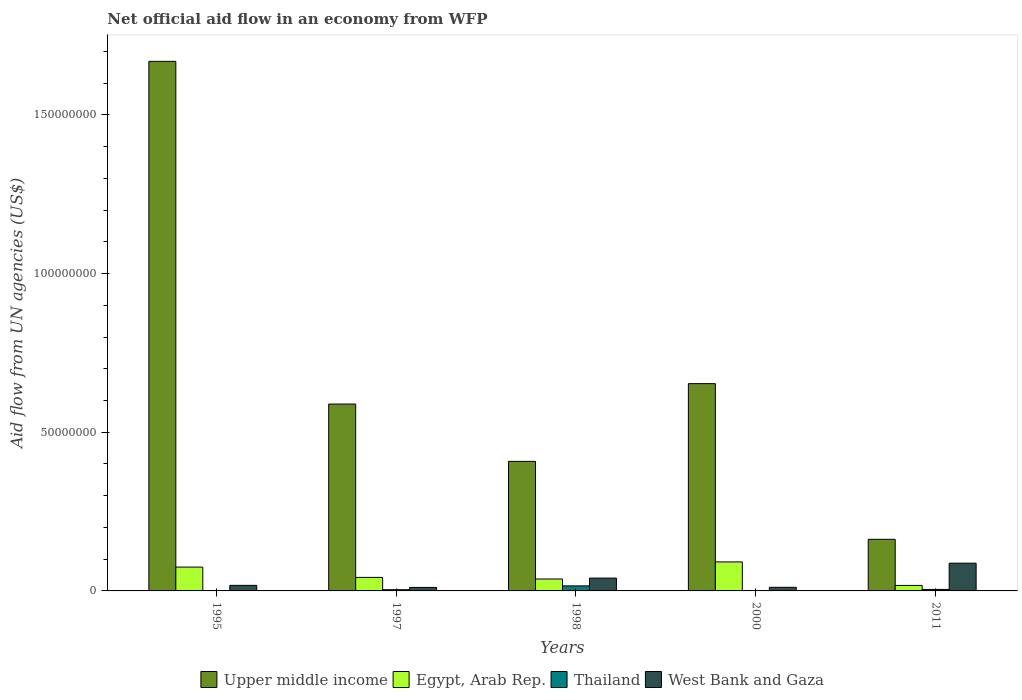How many groups of bars are there?
Provide a succinct answer. 5. Are the number of bars per tick equal to the number of legend labels?
Offer a very short reply. No. Are the number of bars on each tick of the X-axis equal?
Your answer should be very brief. No. How many bars are there on the 4th tick from the right?
Your answer should be very brief. 4. What is the label of the 1st group of bars from the left?
Provide a succinct answer. 1995. In how many cases, is the number of bars for a given year not equal to the number of legend labels?
Give a very brief answer. 1. What is the net official aid flow in Thailand in 2011?
Your answer should be very brief. 4.70e+05. Across all years, what is the maximum net official aid flow in West Bank and Gaza?
Ensure brevity in your answer.  8.74e+06. Across all years, what is the minimum net official aid flow in Upper middle income?
Keep it short and to the point. 1.63e+07. What is the total net official aid flow in West Bank and Gaza in the graph?
Offer a very short reply. 1.68e+07. What is the difference between the net official aid flow in Egypt, Arab Rep. in 1995 and that in 1997?
Your answer should be compact. 3.25e+06. What is the difference between the net official aid flow in Egypt, Arab Rep. in 1997 and the net official aid flow in Thailand in 1995?
Your answer should be very brief. 4.26e+06. What is the average net official aid flow in Egypt, Arab Rep. per year?
Your answer should be very brief. 5.28e+06. In the year 1998, what is the difference between the net official aid flow in Egypt, Arab Rep. and net official aid flow in Upper middle income?
Your answer should be very brief. -3.71e+07. What is the ratio of the net official aid flow in Thailand in 1998 to that in 2011?
Ensure brevity in your answer.  3.38. Is the net official aid flow in Egypt, Arab Rep. in 1998 less than that in 2000?
Your answer should be very brief. Yes. What is the difference between the highest and the second highest net official aid flow in Upper middle income?
Offer a terse response. 1.02e+08. What is the difference between the highest and the lowest net official aid flow in Egypt, Arab Rep.?
Offer a very short reply. 7.41e+06. Does the graph contain grids?
Offer a very short reply. No. Where does the legend appear in the graph?
Keep it short and to the point. Bottom center. What is the title of the graph?
Make the answer very short. Net official aid flow in an economy from WFP. What is the label or title of the X-axis?
Your response must be concise. Years. What is the label or title of the Y-axis?
Offer a very short reply. Aid flow from UN agencies (US$). What is the Aid flow from UN agencies (US$) in Upper middle income in 1995?
Your answer should be very brief. 1.67e+08. What is the Aid flow from UN agencies (US$) in Egypt, Arab Rep. in 1995?
Your answer should be very brief. 7.51e+06. What is the Aid flow from UN agencies (US$) in West Bank and Gaza in 1995?
Ensure brevity in your answer.  1.75e+06. What is the Aid flow from UN agencies (US$) in Upper middle income in 1997?
Your answer should be compact. 5.89e+07. What is the Aid flow from UN agencies (US$) in Egypt, Arab Rep. in 1997?
Keep it short and to the point. 4.26e+06. What is the Aid flow from UN agencies (US$) of Thailand in 1997?
Your answer should be very brief. 3.80e+05. What is the Aid flow from UN agencies (US$) in West Bank and Gaza in 1997?
Your response must be concise. 1.10e+06. What is the Aid flow from UN agencies (US$) in Upper middle income in 1998?
Make the answer very short. 4.08e+07. What is the Aid flow from UN agencies (US$) in Egypt, Arab Rep. in 1998?
Give a very brief answer. 3.76e+06. What is the Aid flow from UN agencies (US$) of Thailand in 1998?
Your response must be concise. 1.59e+06. What is the Aid flow from UN agencies (US$) in West Bank and Gaza in 1998?
Ensure brevity in your answer.  4.05e+06. What is the Aid flow from UN agencies (US$) of Upper middle income in 2000?
Offer a very short reply. 6.53e+07. What is the Aid flow from UN agencies (US$) of Egypt, Arab Rep. in 2000?
Your response must be concise. 9.14e+06. What is the Aid flow from UN agencies (US$) of West Bank and Gaza in 2000?
Ensure brevity in your answer.  1.14e+06. What is the Aid flow from UN agencies (US$) in Upper middle income in 2011?
Provide a succinct answer. 1.63e+07. What is the Aid flow from UN agencies (US$) in Egypt, Arab Rep. in 2011?
Provide a short and direct response. 1.73e+06. What is the Aid flow from UN agencies (US$) of Thailand in 2011?
Ensure brevity in your answer.  4.70e+05. What is the Aid flow from UN agencies (US$) of West Bank and Gaza in 2011?
Ensure brevity in your answer.  8.74e+06. Across all years, what is the maximum Aid flow from UN agencies (US$) of Upper middle income?
Offer a very short reply. 1.67e+08. Across all years, what is the maximum Aid flow from UN agencies (US$) of Egypt, Arab Rep.?
Make the answer very short. 9.14e+06. Across all years, what is the maximum Aid flow from UN agencies (US$) of Thailand?
Ensure brevity in your answer.  1.59e+06. Across all years, what is the maximum Aid flow from UN agencies (US$) in West Bank and Gaza?
Make the answer very short. 8.74e+06. Across all years, what is the minimum Aid flow from UN agencies (US$) in Upper middle income?
Give a very brief answer. 1.63e+07. Across all years, what is the minimum Aid flow from UN agencies (US$) in Egypt, Arab Rep.?
Keep it short and to the point. 1.73e+06. Across all years, what is the minimum Aid flow from UN agencies (US$) in West Bank and Gaza?
Give a very brief answer. 1.10e+06. What is the total Aid flow from UN agencies (US$) of Upper middle income in the graph?
Offer a terse response. 3.48e+08. What is the total Aid flow from UN agencies (US$) of Egypt, Arab Rep. in the graph?
Your response must be concise. 2.64e+07. What is the total Aid flow from UN agencies (US$) in Thailand in the graph?
Provide a short and direct response. 2.47e+06. What is the total Aid flow from UN agencies (US$) of West Bank and Gaza in the graph?
Give a very brief answer. 1.68e+07. What is the difference between the Aid flow from UN agencies (US$) in Upper middle income in 1995 and that in 1997?
Keep it short and to the point. 1.08e+08. What is the difference between the Aid flow from UN agencies (US$) of Egypt, Arab Rep. in 1995 and that in 1997?
Ensure brevity in your answer.  3.25e+06. What is the difference between the Aid flow from UN agencies (US$) of West Bank and Gaza in 1995 and that in 1997?
Your answer should be compact. 6.50e+05. What is the difference between the Aid flow from UN agencies (US$) of Upper middle income in 1995 and that in 1998?
Make the answer very short. 1.26e+08. What is the difference between the Aid flow from UN agencies (US$) of Egypt, Arab Rep. in 1995 and that in 1998?
Your response must be concise. 3.75e+06. What is the difference between the Aid flow from UN agencies (US$) of West Bank and Gaza in 1995 and that in 1998?
Your answer should be compact. -2.30e+06. What is the difference between the Aid flow from UN agencies (US$) in Upper middle income in 1995 and that in 2000?
Make the answer very short. 1.02e+08. What is the difference between the Aid flow from UN agencies (US$) of Egypt, Arab Rep. in 1995 and that in 2000?
Your response must be concise. -1.63e+06. What is the difference between the Aid flow from UN agencies (US$) in West Bank and Gaza in 1995 and that in 2000?
Offer a very short reply. 6.10e+05. What is the difference between the Aid flow from UN agencies (US$) of Upper middle income in 1995 and that in 2011?
Provide a short and direct response. 1.51e+08. What is the difference between the Aid flow from UN agencies (US$) of Egypt, Arab Rep. in 1995 and that in 2011?
Your response must be concise. 5.78e+06. What is the difference between the Aid flow from UN agencies (US$) in West Bank and Gaza in 1995 and that in 2011?
Make the answer very short. -6.99e+06. What is the difference between the Aid flow from UN agencies (US$) in Upper middle income in 1997 and that in 1998?
Your answer should be compact. 1.81e+07. What is the difference between the Aid flow from UN agencies (US$) in Egypt, Arab Rep. in 1997 and that in 1998?
Provide a succinct answer. 5.00e+05. What is the difference between the Aid flow from UN agencies (US$) of Thailand in 1997 and that in 1998?
Offer a very short reply. -1.21e+06. What is the difference between the Aid flow from UN agencies (US$) in West Bank and Gaza in 1997 and that in 1998?
Provide a succinct answer. -2.95e+06. What is the difference between the Aid flow from UN agencies (US$) of Upper middle income in 1997 and that in 2000?
Offer a terse response. -6.43e+06. What is the difference between the Aid flow from UN agencies (US$) in Egypt, Arab Rep. in 1997 and that in 2000?
Offer a very short reply. -4.88e+06. What is the difference between the Aid flow from UN agencies (US$) in Thailand in 1997 and that in 2000?
Your answer should be compact. 3.50e+05. What is the difference between the Aid flow from UN agencies (US$) in West Bank and Gaza in 1997 and that in 2000?
Make the answer very short. -4.00e+04. What is the difference between the Aid flow from UN agencies (US$) of Upper middle income in 1997 and that in 2011?
Ensure brevity in your answer.  4.26e+07. What is the difference between the Aid flow from UN agencies (US$) of Egypt, Arab Rep. in 1997 and that in 2011?
Your response must be concise. 2.53e+06. What is the difference between the Aid flow from UN agencies (US$) of West Bank and Gaza in 1997 and that in 2011?
Your answer should be very brief. -7.64e+06. What is the difference between the Aid flow from UN agencies (US$) of Upper middle income in 1998 and that in 2000?
Ensure brevity in your answer.  -2.45e+07. What is the difference between the Aid flow from UN agencies (US$) of Egypt, Arab Rep. in 1998 and that in 2000?
Give a very brief answer. -5.38e+06. What is the difference between the Aid flow from UN agencies (US$) in Thailand in 1998 and that in 2000?
Give a very brief answer. 1.56e+06. What is the difference between the Aid flow from UN agencies (US$) in West Bank and Gaza in 1998 and that in 2000?
Make the answer very short. 2.91e+06. What is the difference between the Aid flow from UN agencies (US$) of Upper middle income in 1998 and that in 2011?
Provide a succinct answer. 2.46e+07. What is the difference between the Aid flow from UN agencies (US$) in Egypt, Arab Rep. in 1998 and that in 2011?
Your answer should be very brief. 2.03e+06. What is the difference between the Aid flow from UN agencies (US$) in Thailand in 1998 and that in 2011?
Provide a succinct answer. 1.12e+06. What is the difference between the Aid flow from UN agencies (US$) in West Bank and Gaza in 1998 and that in 2011?
Your answer should be compact. -4.69e+06. What is the difference between the Aid flow from UN agencies (US$) of Upper middle income in 2000 and that in 2011?
Give a very brief answer. 4.91e+07. What is the difference between the Aid flow from UN agencies (US$) of Egypt, Arab Rep. in 2000 and that in 2011?
Offer a very short reply. 7.41e+06. What is the difference between the Aid flow from UN agencies (US$) of Thailand in 2000 and that in 2011?
Offer a terse response. -4.40e+05. What is the difference between the Aid flow from UN agencies (US$) in West Bank and Gaza in 2000 and that in 2011?
Your answer should be very brief. -7.60e+06. What is the difference between the Aid flow from UN agencies (US$) in Upper middle income in 1995 and the Aid flow from UN agencies (US$) in Egypt, Arab Rep. in 1997?
Your response must be concise. 1.63e+08. What is the difference between the Aid flow from UN agencies (US$) of Upper middle income in 1995 and the Aid flow from UN agencies (US$) of Thailand in 1997?
Make the answer very short. 1.66e+08. What is the difference between the Aid flow from UN agencies (US$) in Upper middle income in 1995 and the Aid flow from UN agencies (US$) in West Bank and Gaza in 1997?
Your answer should be compact. 1.66e+08. What is the difference between the Aid flow from UN agencies (US$) in Egypt, Arab Rep. in 1995 and the Aid flow from UN agencies (US$) in Thailand in 1997?
Provide a short and direct response. 7.13e+06. What is the difference between the Aid flow from UN agencies (US$) of Egypt, Arab Rep. in 1995 and the Aid flow from UN agencies (US$) of West Bank and Gaza in 1997?
Your answer should be compact. 6.41e+06. What is the difference between the Aid flow from UN agencies (US$) in Upper middle income in 1995 and the Aid flow from UN agencies (US$) in Egypt, Arab Rep. in 1998?
Offer a terse response. 1.63e+08. What is the difference between the Aid flow from UN agencies (US$) in Upper middle income in 1995 and the Aid flow from UN agencies (US$) in Thailand in 1998?
Keep it short and to the point. 1.65e+08. What is the difference between the Aid flow from UN agencies (US$) in Upper middle income in 1995 and the Aid flow from UN agencies (US$) in West Bank and Gaza in 1998?
Provide a succinct answer. 1.63e+08. What is the difference between the Aid flow from UN agencies (US$) in Egypt, Arab Rep. in 1995 and the Aid flow from UN agencies (US$) in Thailand in 1998?
Your answer should be very brief. 5.92e+06. What is the difference between the Aid flow from UN agencies (US$) in Egypt, Arab Rep. in 1995 and the Aid flow from UN agencies (US$) in West Bank and Gaza in 1998?
Provide a short and direct response. 3.46e+06. What is the difference between the Aid flow from UN agencies (US$) in Upper middle income in 1995 and the Aid flow from UN agencies (US$) in Egypt, Arab Rep. in 2000?
Provide a short and direct response. 1.58e+08. What is the difference between the Aid flow from UN agencies (US$) in Upper middle income in 1995 and the Aid flow from UN agencies (US$) in Thailand in 2000?
Offer a very short reply. 1.67e+08. What is the difference between the Aid flow from UN agencies (US$) in Upper middle income in 1995 and the Aid flow from UN agencies (US$) in West Bank and Gaza in 2000?
Ensure brevity in your answer.  1.66e+08. What is the difference between the Aid flow from UN agencies (US$) in Egypt, Arab Rep. in 1995 and the Aid flow from UN agencies (US$) in Thailand in 2000?
Offer a very short reply. 7.48e+06. What is the difference between the Aid flow from UN agencies (US$) of Egypt, Arab Rep. in 1995 and the Aid flow from UN agencies (US$) of West Bank and Gaza in 2000?
Make the answer very short. 6.37e+06. What is the difference between the Aid flow from UN agencies (US$) of Upper middle income in 1995 and the Aid flow from UN agencies (US$) of Egypt, Arab Rep. in 2011?
Provide a succinct answer. 1.65e+08. What is the difference between the Aid flow from UN agencies (US$) of Upper middle income in 1995 and the Aid flow from UN agencies (US$) of Thailand in 2011?
Give a very brief answer. 1.66e+08. What is the difference between the Aid flow from UN agencies (US$) of Upper middle income in 1995 and the Aid flow from UN agencies (US$) of West Bank and Gaza in 2011?
Offer a terse response. 1.58e+08. What is the difference between the Aid flow from UN agencies (US$) in Egypt, Arab Rep. in 1995 and the Aid flow from UN agencies (US$) in Thailand in 2011?
Your answer should be very brief. 7.04e+06. What is the difference between the Aid flow from UN agencies (US$) in Egypt, Arab Rep. in 1995 and the Aid flow from UN agencies (US$) in West Bank and Gaza in 2011?
Your answer should be compact. -1.23e+06. What is the difference between the Aid flow from UN agencies (US$) of Upper middle income in 1997 and the Aid flow from UN agencies (US$) of Egypt, Arab Rep. in 1998?
Offer a very short reply. 5.51e+07. What is the difference between the Aid flow from UN agencies (US$) in Upper middle income in 1997 and the Aid flow from UN agencies (US$) in Thailand in 1998?
Keep it short and to the point. 5.73e+07. What is the difference between the Aid flow from UN agencies (US$) of Upper middle income in 1997 and the Aid flow from UN agencies (US$) of West Bank and Gaza in 1998?
Offer a very short reply. 5.48e+07. What is the difference between the Aid flow from UN agencies (US$) in Egypt, Arab Rep. in 1997 and the Aid flow from UN agencies (US$) in Thailand in 1998?
Give a very brief answer. 2.67e+06. What is the difference between the Aid flow from UN agencies (US$) in Egypt, Arab Rep. in 1997 and the Aid flow from UN agencies (US$) in West Bank and Gaza in 1998?
Your answer should be compact. 2.10e+05. What is the difference between the Aid flow from UN agencies (US$) of Thailand in 1997 and the Aid flow from UN agencies (US$) of West Bank and Gaza in 1998?
Offer a terse response. -3.67e+06. What is the difference between the Aid flow from UN agencies (US$) of Upper middle income in 1997 and the Aid flow from UN agencies (US$) of Egypt, Arab Rep. in 2000?
Ensure brevity in your answer.  4.98e+07. What is the difference between the Aid flow from UN agencies (US$) in Upper middle income in 1997 and the Aid flow from UN agencies (US$) in Thailand in 2000?
Offer a terse response. 5.89e+07. What is the difference between the Aid flow from UN agencies (US$) of Upper middle income in 1997 and the Aid flow from UN agencies (US$) of West Bank and Gaza in 2000?
Keep it short and to the point. 5.78e+07. What is the difference between the Aid flow from UN agencies (US$) of Egypt, Arab Rep. in 1997 and the Aid flow from UN agencies (US$) of Thailand in 2000?
Offer a terse response. 4.23e+06. What is the difference between the Aid flow from UN agencies (US$) in Egypt, Arab Rep. in 1997 and the Aid flow from UN agencies (US$) in West Bank and Gaza in 2000?
Your response must be concise. 3.12e+06. What is the difference between the Aid flow from UN agencies (US$) in Thailand in 1997 and the Aid flow from UN agencies (US$) in West Bank and Gaza in 2000?
Ensure brevity in your answer.  -7.60e+05. What is the difference between the Aid flow from UN agencies (US$) in Upper middle income in 1997 and the Aid flow from UN agencies (US$) in Egypt, Arab Rep. in 2011?
Give a very brief answer. 5.72e+07. What is the difference between the Aid flow from UN agencies (US$) in Upper middle income in 1997 and the Aid flow from UN agencies (US$) in Thailand in 2011?
Make the answer very short. 5.84e+07. What is the difference between the Aid flow from UN agencies (US$) in Upper middle income in 1997 and the Aid flow from UN agencies (US$) in West Bank and Gaza in 2011?
Offer a very short reply. 5.02e+07. What is the difference between the Aid flow from UN agencies (US$) of Egypt, Arab Rep. in 1997 and the Aid flow from UN agencies (US$) of Thailand in 2011?
Your answer should be compact. 3.79e+06. What is the difference between the Aid flow from UN agencies (US$) of Egypt, Arab Rep. in 1997 and the Aid flow from UN agencies (US$) of West Bank and Gaza in 2011?
Provide a succinct answer. -4.48e+06. What is the difference between the Aid flow from UN agencies (US$) in Thailand in 1997 and the Aid flow from UN agencies (US$) in West Bank and Gaza in 2011?
Your answer should be very brief. -8.36e+06. What is the difference between the Aid flow from UN agencies (US$) in Upper middle income in 1998 and the Aid flow from UN agencies (US$) in Egypt, Arab Rep. in 2000?
Provide a short and direct response. 3.17e+07. What is the difference between the Aid flow from UN agencies (US$) in Upper middle income in 1998 and the Aid flow from UN agencies (US$) in Thailand in 2000?
Make the answer very short. 4.08e+07. What is the difference between the Aid flow from UN agencies (US$) in Upper middle income in 1998 and the Aid flow from UN agencies (US$) in West Bank and Gaza in 2000?
Ensure brevity in your answer.  3.97e+07. What is the difference between the Aid flow from UN agencies (US$) in Egypt, Arab Rep. in 1998 and the Aid flow from UN agencies (US$) in Thailand in 2000?
Your response must be concise. 3.73e+06. What is the difference between the Aid flow from UN agencies (US$) of Egypt, Arab Rep. in 1998 and the Aid flow from UN agencies (US$) of West Bank and Gaza in 2000?
Your answer should be very brief. 2.62e+06. What is the difference between the Aid flow from UN agencies (US$) in Upper middle income in 1998 and the Aid flow from UN agencies (US$) in Egypt, Arab Rep. in 2011?
Your response must be concise. 3.91e+07. What is the difference between the Aid flow from UN agencies (US$) of Upper middle income in 1998 and the Aid flow from UN agencies (US$) of Thailand in 2011?
Your answer should be very brief. 4.04e+07. What is the difference between the Aid flow from UN agencies (US$) of Upper middle income in 1998 and the Aid flow from UN agencies (US$) of West Bank and Gaza in 2011?
Your response must be concise. 3.21e+07. What is the difference between the Aid flow from UN agencies (US$) of Egypt, Arab Rep. in 1998 and the Aid flow from UN agencies (US$) of Thailand in 2011?
Your response must be concise. 3.29e+06. What is the difference between the Aid flow from UN agencies (US$) of Egypt, Arab Rep. in 1998 and the Aid flow from UN agencies (US$) of West Bank and Gaza in 2011?
Offer a very short reply. -4.98e+06. What is the difference between the Aid flow from UN agencies (US$) in Thailand in 1998 and the Aid flow from UN agencies (US$) in West Bank and Gaza in 2011?
Provide a succinct answer. -7.15e+06. What is the difference between the Aid flow from UN agencies (US$) in Upper middle income in 2000 and the Aid flow from UN agencies (US$) in Egypt, Arab Rep. in 2011?
Your response must be concise. 6.36e+07. What is the difference between the Aid flow from UN agencies (US$) of Upper middle income in 2000 and the Aid flow from UN agencies (US$) of Thailand in 2011?
Offer a terse response. 6.48e+07. What is the difference between the Aid flow from UN agencies (US$) of Upper middle income in 2000 and the Aid flow from UN agencies (US$) of West Bank and Gaza in 2011?
Your answer should be compact. 5.66e+07. What is the difference between the Aid flow from UN agencies (US$) of Egypt, Arab Rep. in 2000 and the Aid flow from UN agencies (US$) of Thailand in 2011?
Offer a terse response. 8.67e+06. What is the difference between the Aid flow from UN agencies (US$) of Thailand in 2000 and the Aid flow from UN agencies (US$) of West Bank and Gaza in 2011?
Provide a succinct answer. -8.71e+06. What is the average Aid flow from UN agencies (US$) in Upper middle income per year?
Offer a very short reply. 6.96e+07. What is the average Aid flow from UN agencies (US$) of Egypt, Arab Rep. per year?
Offer a very short reply. 5.28e+06. What is the average Aid flow from UN agencies (US$) of Thailand per year?
Keep it short and to the point. 4.94e+05. What is the average Aid flow from UN agencies (US$) of West Bank and Gaza per year?
Offer a terse response. 3.36e+06. In the year 1995, what is the difference between the Aid flow from UN agencies (US$) of Upper middle income and Aid flow from UN agencies (US$) of Egypt, Arab Rep.?
Make the answer very short. 1.59e+08. In the year 1995, what is the difference between the Aid flow from UN agencies (US$) of Upper middle income and Aid flow from UN agencies (US$) of West Bank and Gaza?
Provide a succinct answer. 1.65e+08. In the year 1995, what is the difference between the Aid flow from UN agencies (US$) in Egypt, Arab Rep. and Aid flow from UN agencies (US$) in West Bank and Gaza?
Offer a terse response. 5.76e+06. In the year 1997, what is the difference between the Aid flow from UN agencies (US$) in Upper middle income and Aid flow from UN agencies (US$) in Egypt, Arab Rep.?
Your response must be concise. 5.46e+07. In the year 1997, what is the difference between the Aid flow from UN agencies (US$) of Upper middle income and Aid flow from UN agencies (US$) of Thailand?
Ensure brevity in your answer.  5.85e+07. In the year 1997, what is the difference between the Aid flow from UN agencies (US$) of Upper middle income and Aid flow from UN agencies (US$) of West Bank and Gaza?
Your response must be concise. 5.78e+07. In the year 1997, what is the difference between the Aid flow from UN agencies (US$) in Egypt, Arab Rep. and Aid flow from UN agencies (US$) in Thailand?
Give a very brief answer. 3.88e+06. In the year 1997, what is the difference between the Aid flow from UN agencies (US$) of Egypt, Arab Rep. and Aid flow from UN agencies (US$) of West Bank and Gaza?
Provide a succinct answer. 3.16e+06. In the year 1997, what is the difference between the Aid flow from UN agencies (US$) in Thailand and Aid flow from UN agencies (US$) in West Bank and Gaza?
Provide a succinct answer. -7.20e+05. In the year 1998, what is the difference between the Aid flow from UN agencies (US$) of Upper middle income and Aid flow from UN agencies (US$) of Egypt, Arab Rep.?
Ensure brevity in your answer.  3.71e+07. In the year 1998, what is the difference between the Aid flow from UN agencies (US$) in Upper middle income and Aid flow from UN agencies (US$) in Thailand?
Your answer should be very brief. 3.92e+07. In the year 1998, what is the difference between the Aid flow from UN agencies (US$) in Upper middle income and Aid flow from UN agencies (US$) in West Bank and Gaza?
Make the answer very short. 3.68e+07. In the year 1998, what is the difference between the Aid flow from UN agencies (US$) in Egypt, Arab Rep. and Aid flow from UN agencies (US$) in Thailand?
Your answer should be very brief. 2.17e+06. In the year 1998, what is the difference between the Aid flow from UN agencies (US$) in Egypt, Arab Rep. and Aid flow from UN agencies (US$) in West Bank and Gaza?
Provide a succinct answer. -2.90e+05. In the year 1998, what is the difference between the Aid flow from UN agencies (US$) of Thailand and Aid flow from UN agencies (US$) of West Bank and Gaza?
Your answer should be compact. -2.46e+06. In the year 2000, what is the difference between the Aid flow from UN agencies (US$) in Upper middle income and Aid flow from UN agencies (US$) in Egypt, Arab Rep.?
Provide a short and direct response. 5.62e+07. In the year 2000, what is the difference between the Aid flow from UN agencies (US$) in Upper middle income and Aid flow from UN agencies (US$) in Thailand?
Ensure brevity in your answer.  6.53e+07. In the year 2000, what is the difference between the Aid flow from UN agencies (US$) of Upper middle income and Aid flow from UN agencies (US$) of West Bank and Gaza?
Give a very brief answer. 6.42e+07. In the year 2000, what is the difference between the Aid flow from UN agencies (US$) of Egypt, Arab Rep. and Aid flow from UN agencies (US$) of Thailand?
Offer a terse response. 9.11e+06. In the year 2000, what is the difference between the Aid flow from UN agencies (US$) of Egypt, Arab Rep. and Aid flow from UN agencies (US$) of West Bank and Gaza?
Provide a succinct answer. 8.00e+06. In the year 2000, what is the difference between the Aid flow from UN agencies (US$) in Thailand and Aid flow from UN agencies (US$) in West Bank and Gaza?
Provide a succinct answer. -1.11e+06. In the year 2011, what is the difference between the Aid flow from UN agencies (US$) in Upper middle income and Aid flow from UN agencies (US$) in Egypt, Arab Rep.?
Keep it short and to the point. 1.45e+07. In the year 2011, what is the difference between the Aid flow from UN agencies (US$) of Upper middle income and Aid flow from UN agencies (US$) of Thailand?
Provide a succinct answer. 1.58e+07. In the year 2011, what is the difference between the Aid flow from UN agencies (US$) of Upper middle income and Aid flow from UN agencies (US$) of West Bank and Gaza?
Provide a short and direct response. 7.52e+06. In the year 2011, what is the difference between the Aid flow from UN agencies (US$) in Egypt, Arab Rep. and Aid flow from UN agencies (US$) in Thailand?
Give a very brief answer. 1.26e+06. In the year 2011, what is the difference between the Aid flow from UN agencies (US$) in Egypt, Arab Rep. and Aid flow from UN agencies (US$) in West Bank and Gaza?
Provide a succinct answer. -7.01e+06. In the year 2011, what is the difference between the Aid flow from UN agencies (US$) of Thailand and Aid flow from UN agencies (US$) of West Bank and Gaza?
Your answer should be very brief. -8.27e+06. What is the ratio of the Aid flow from UN agencies (US$) of Upper middle income in 1995 to that in 1997?
Provide a short and direct response. 2.83. What is the ratio of the Aid flow from UN agencies (US$) in Egypt, Arab Rep. in 1995 to that in 1997?
Keep it short and to the point. 1.76. What is the ratio of the Aid flow from UN agencies (US$) of West Bank and Gaza in 1995 to that in 1997?
Offer a very short reply. 1.59. What is the ratio of the Aid flow from UN agencies (US$) of Upper middle income in 1995 to that in 1998?
Keep it short and to the point. 4.09. What is the ratio of the Aid flow from UN agencies (US$) in Egypt, Arab Rep. in 1995 to that in 1998?
Your answer should be compact. 2. What is the ratio of the Aid flow from UN agencies (US$) in West Bank and Gaza in 1995 to that in 1998?
Offer a very short reply. 0.43. What is the ratio of the Aid flow from UN agencies (US$) in Upper middle income in 1995 to that in 2000?
Give a very brief answer. 2.55. What is the ratio of the Aid flow from UN agencies (US$) of Egypt, Arab Rep. in 1995 to that in 2000?
Ensure brevity in your answer.  0.82. What is the ratio of the Aid flow from UN agencies (US$) in West Bank and Gaza in 1995 to that in 2000?
Your answer should be compact. 1.54. What is the ratio of the Aid flow from UN agencies (US$) of Upper middle income in 1995 to that in 2011?
Provide a short and direct response. 10.26. What is the ratio of the Aid flow from UN agencies (US$) in Egypt, Arab Rep. in 1995 to that in 2011?
Offer a terse response. 4.34. What is the ratio of the Aid flow from UN agencies (US$) of West Bank and Gaza in 1995 to that in 2011?
Your answer should be very brief. 0.2. What is the ratio of the Aid flow from UN agencies (US$) of Upper middle income in 1997 to that in 1998?
Provide a succinct answer. 1.44. What is the ratio of the Aid flow from UN agencies (US$) in Egypt, Arab Rep. in 1997 to that in 1998?
Give a very brief answer. 1.13. What is the ratio of the Aid flow from UN agencies (US$) in Thailand in 1997 to that in 1998?
Offer a terse response. 0.24. What is the ratio of the Aid flow from UN agencies (US$) of West Bank and Gaza in 1997 to that in 1998?
Give a very brief answer. 0.27. What is the ratio of the Aid flow from UN agencies (US$) of Upper middle income in 1997 to that in 2000?
Your response must be concise. 0.9. What is the ratio of the Aid flow from UN agencies (US$) in Egypt, Arab Rep. in 1997 to that in 2000?
Provide a succinct answer. 0.47. What is the ratio of the Aid flow from UN agencies (US$) in Thailand in 1997 to that in 2000?
Offer a terse response. 12.67. What is the ratio of the Aid flow from UN agencies (US$) in West Bank and Gaza in 1997 to that in 2000?
Provide a succinct answer. 0.96. What is the ratio of the Aid flow from UN agencies (US$) of Upper middle income in 1997 to that in 2011?
Your answer should be very brief. 3.62. What is the ratio of the Aid flow from UN agencies (US$) of Egypt, Arab Rep. in 1997 to that in 2011?
Keep it short and to the point. 2.46. What is the ratio of the Aid flow from UN agencies (US$) in Thailand in 1997 to that in 2011?
Your answer should be very brief. 0.81. What is the ratio of the Aid flow from UN agencies (US$) of West Bank and Gaza in 1997 to that in 2011?
Make the answer very short. 0.13. What is the ratio of the Aid flow from UN agencies (US$) of Upper middle income in 1998 to that in 2000?
Your answer should be compact. 0.62. What is the ratio of the Aid flow from UN agencies (US$) of Egypt, Arab Rep. in 1998 to that in 2000?
Offer a terse response. 0.41. What is the ratio of the Aid flow from UN agencies (US$) of Thailand in 1998 to that in 2000?
Ensure brevity in your answer.  53. What is the ratio of the Aid flow from UN agencies (US$) in West Bank and Gaza in 1998 to that in 2000?
Your response must be concise. 3.55. What is the ratio of the Aid flow from UN agencies (US$) of Upper middle income in 1998 to that in 2011?
Make the answer very short. 2.51. What is the ratio of the Aid flow from UN agencies (US$) in Egypt, Arab Rep. in 1998 to that in 2011?
Provide a succinct answer. 2.17. What is the ratio of the Aid flow from UN agencies (US$) in Thailand in 1998 to that in 2011?
Offer a terse response. 3.38. What is the ratio of the Aid flow from UN agencies (US$) in West Bank and Gaza in 1998 to that in 2011?
Offer a terse response. 0.46. What is the ratio of the Aid flow from UN agencies (US$) of Upper middle income in 2000 to that in 2011?
Keep it short and to the point. 4.02. What is the ratio of the Aid flow from UN agencies (US$) of Egypt, Arab Rep. in 2000 to that in 2011?
Offer a terse response. 5.28. What is the ratio of the Aid flow from UN agencies (US$) in Thailand in 2000 to that in 2011?
Provide a short and direct response. 0.06. What is the ratio of the Aid flow from UN agencies (US$) in West Bank and Gaza in 2000 to that in 2011?
Offer a very short reply. 0.13. What is the difference between the highest and the second highest Aid flow from UN agencies (US$) in Upper middle income?
Offer a terse response. 1.02e+08. What is the difference between the highest and the second highest Aid flow from UN agencies (US$) of Egypt, Arab Rep.?
Offer a very short reply. 1.63e+06. What is the difference between the highest and the second highest Aid flow from UN agencies (US$) of Thailand?
Your answer should be very brief. 1.12e+06. What is the difference between the highest and the second highest Aid flow from UN agencies (US$) in West Bank and Gaza?
Provide a succinct answer. 4.69e+06. What is the difference between the highest and the lowest Aid flow from UN agencies (US$) of Upper middle income?
Provide a short and direct response. 1.51e+08. What is the difference between the highest and the lowest Aid flow from UN agencies (US$) of Egypt, Arab Rep.?
Offer a very short reply. 7.41e+06. What is the difference between the highest and the lowest Aid flow from UN agencies (US$) in Thailand?
Your answer should be compact. 1.59e+06. What is the difference between the highest and the lowest Aid flow from UN agencies (US$) in West Bank and Gaza?
Keep it short and to the point. 7.64e+06. 